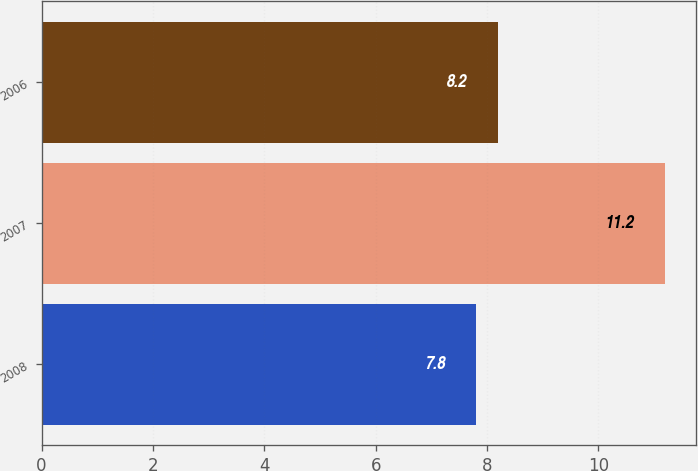<chart> <loc_0><loc_0><loc_500><loc_500><bar_chart><fcel>2008<fcel>2007<fcel>2006<nl><fcel>7.8<fcel>11.2<fcel>8.2<nl></chart> 